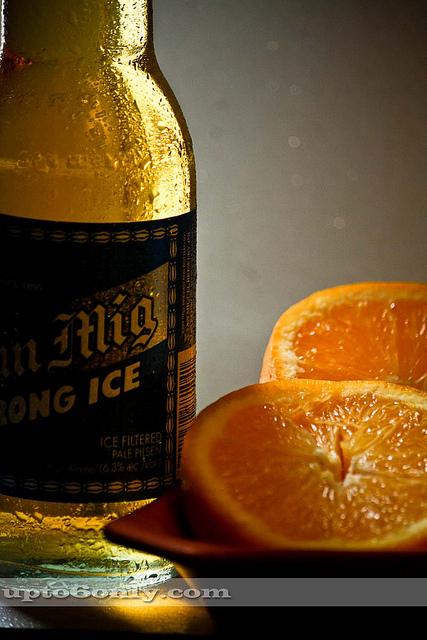What fruit is pictured next to the bottle?
Short answer required. Orange. What website did this picture come from?
Write a very short answer. Upto6onlycom. Is the bottle full?
Write a very short answer. Yes. What does the bottle contain?
Answer briefly. Beer. 